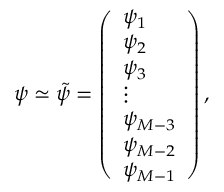Convert formula to latex. <formula><loc_0><loc_0><loc_500><loc_500>\psi \simeq \tilde { \psi } = \left ( \begin{array} { l } { \psi _ { 1 } } \\ { \psi _ { 2 } } \\ { \psi _ { 3 } } \\ { \vdots } \\ { \psi _ { M - 3 } } \\ { \psi _ { M - 2 } } \\ { \psi _ { M - 1 } } \end{array} \right ) ,</formula> 